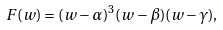Convert formula to latex. <formula><loc_0><loc_0><loc_500><loc_500>F ( w ) = ( w - \alpha ) ^ { 3 } ( w - \beta ) ( w - \gamma ) ,</formula> 